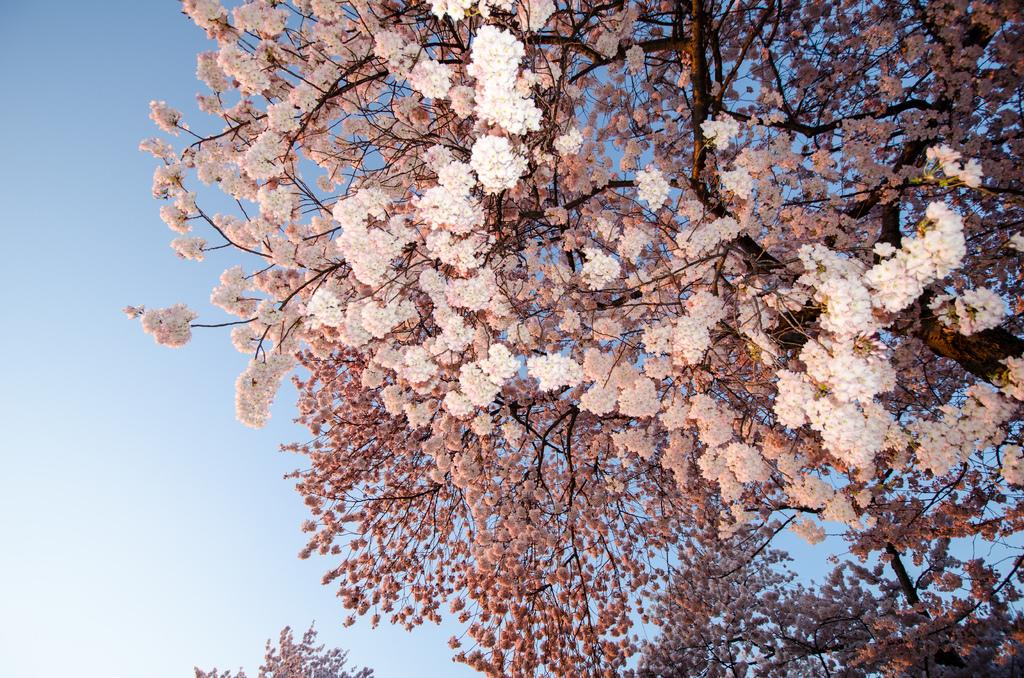What type of vegetation can be seen in the image? There are trees in the image. What additional feature can be observed on the trees? The trees have flowers on them. What part of the natural environment is visible in the image? The sky is visible in the image. What type of comb is being used to style the family's hair in the image? There is no comb or family present in the image; it features trees with flowers and a visible sky. 